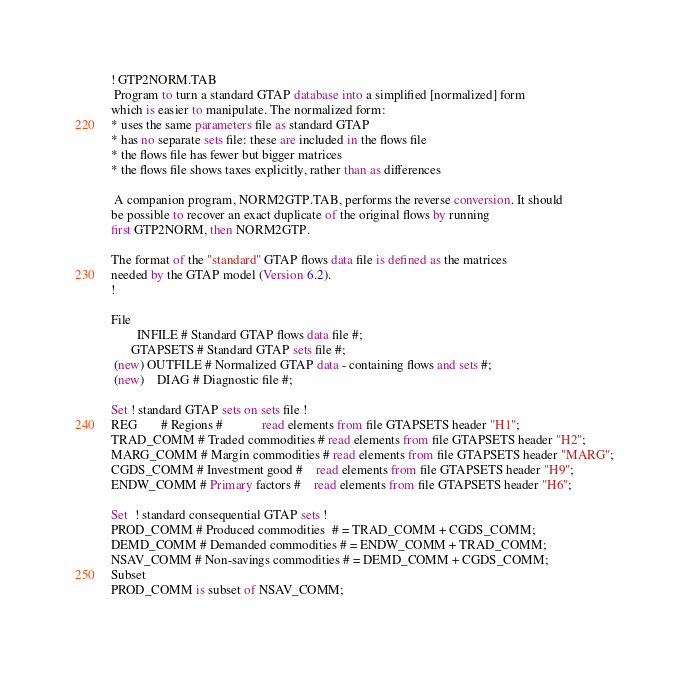Convert code to text. <code><loc_0><loc_0><loc_500><loc_500><_SQL_>! GTP2NORM.TAB
 Program to turn a standard GTAP database into a simplified [normalized] form
which is easier to manipulate. The normalized form:
* uses the same parameters file as standard GTAP
* has no separate sets file: these are included in the flows file
* the flows file has fewer but bigger matrices 
* the flows file shows taxes explicitly, rather than as differences

 A companion program, NORM2GTP.TAB, performs the reverse conversion. It should
be possible to recover an exact duplicate of the original flows by running
first GTP2NORM, then NORM2GTP.

The format of the "standard" GTAP flows data file is defined as the matrices
needed by the GTAP model (Version 6.2). 
!

File
        INFILE # Standard GTAP flows data file #;
      GTAPSETS # Standard GTAP sets file #;
 (new) OUTFILE # Normalized GTAP data - containing flows and sets #;
 (new)    DIAG # Diagnostic file #;

Set ! standard GTAP sets on sets file !
REG       # Regions #            read elements from file GTAPSETS header "H1";
TRAD_COMM # Traded commodities # read elements from file GTAPSETS header "H2";
MARG_COMM # Margin commodities # read elements from file GTAPSETS header "MARG";
CGDS_COMM # Investment good #    read elements from file GTAPSETS header "H9";
ENDW_COMM # Primary factors #    read elements from file GTAPSETS header "H6";

Set  ! standard consequential GTAP sets !
PROD_COMM # Produced commodities  # = TRAD_COMM + CGDS_COMM;
DEMD_COMM # Demanded commodities # = ENDW_COMM + TRAD_COMM;
NSAV_COMM # Non-savings commodities # = DEMD_COMM + CGDS_COMM;
Subset
PROD_COMM is subset of NSAV_COMM;</code> 